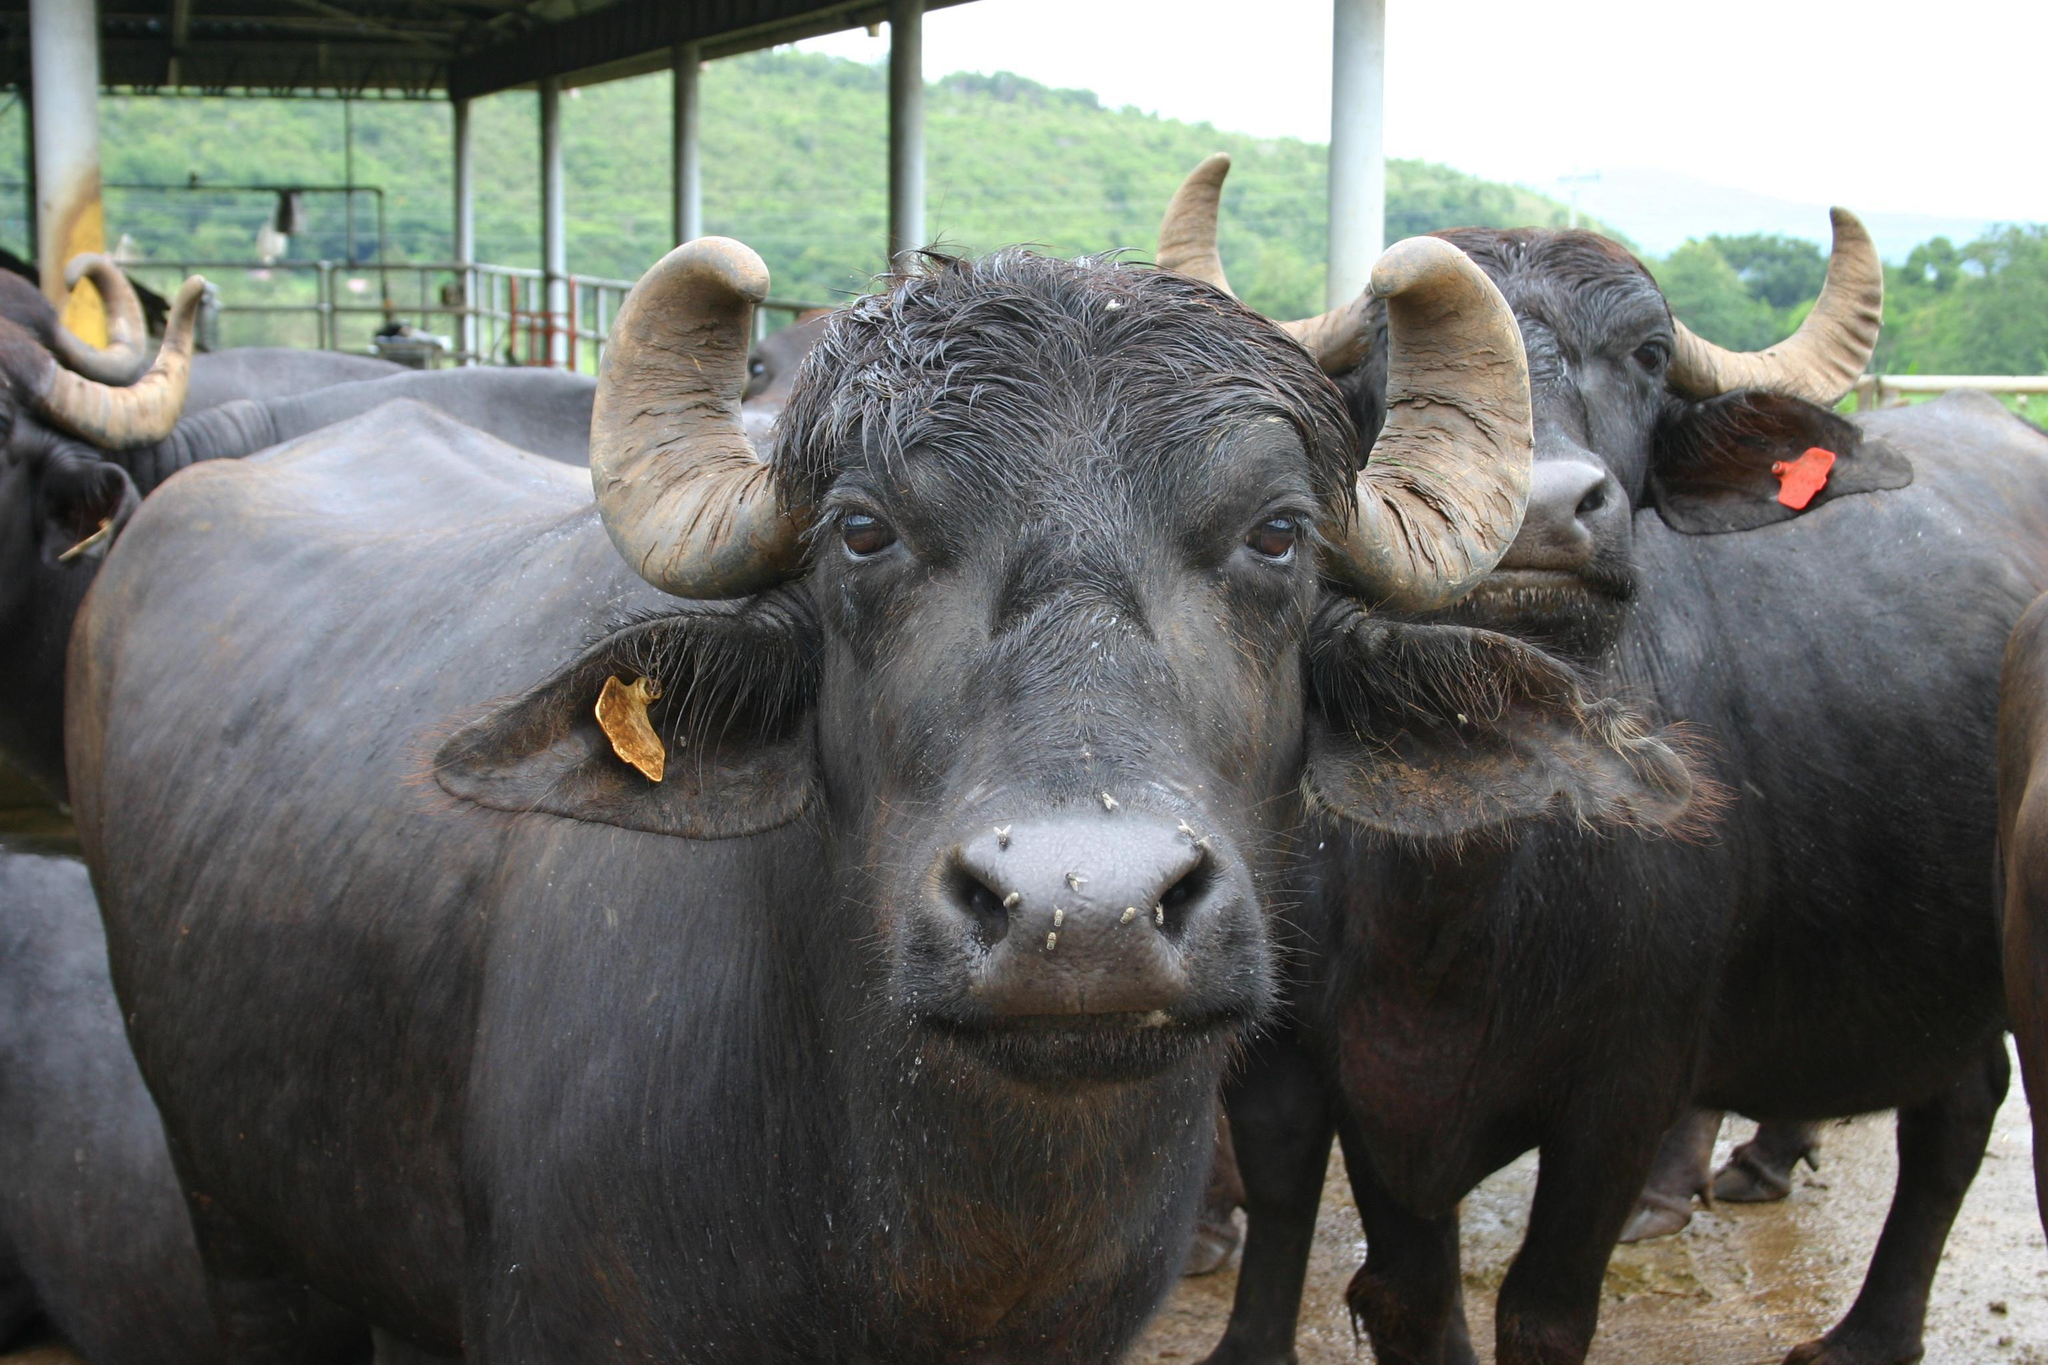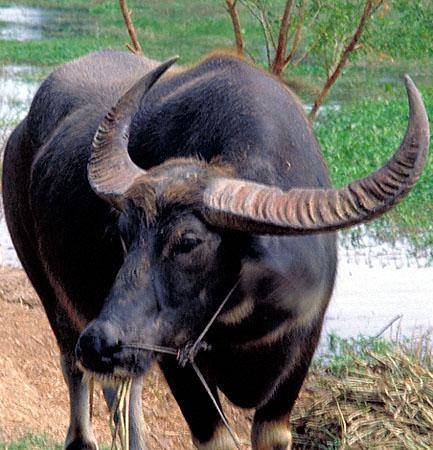The first image is the image on the left, the second image is the image on the right. Examine the images to the left and right. Is the description "The foreground of each image contains water buffalo who look directly forward, and one image contains a single water buffalo in the foreground." accurate? Answer yes or no. No. The first image is the image on the left, the second image is the image on the right. Analyze the images presented: Is the assertion "The animals in the left image are next to a man made structure." valid? Answer yes or no. Yes. 